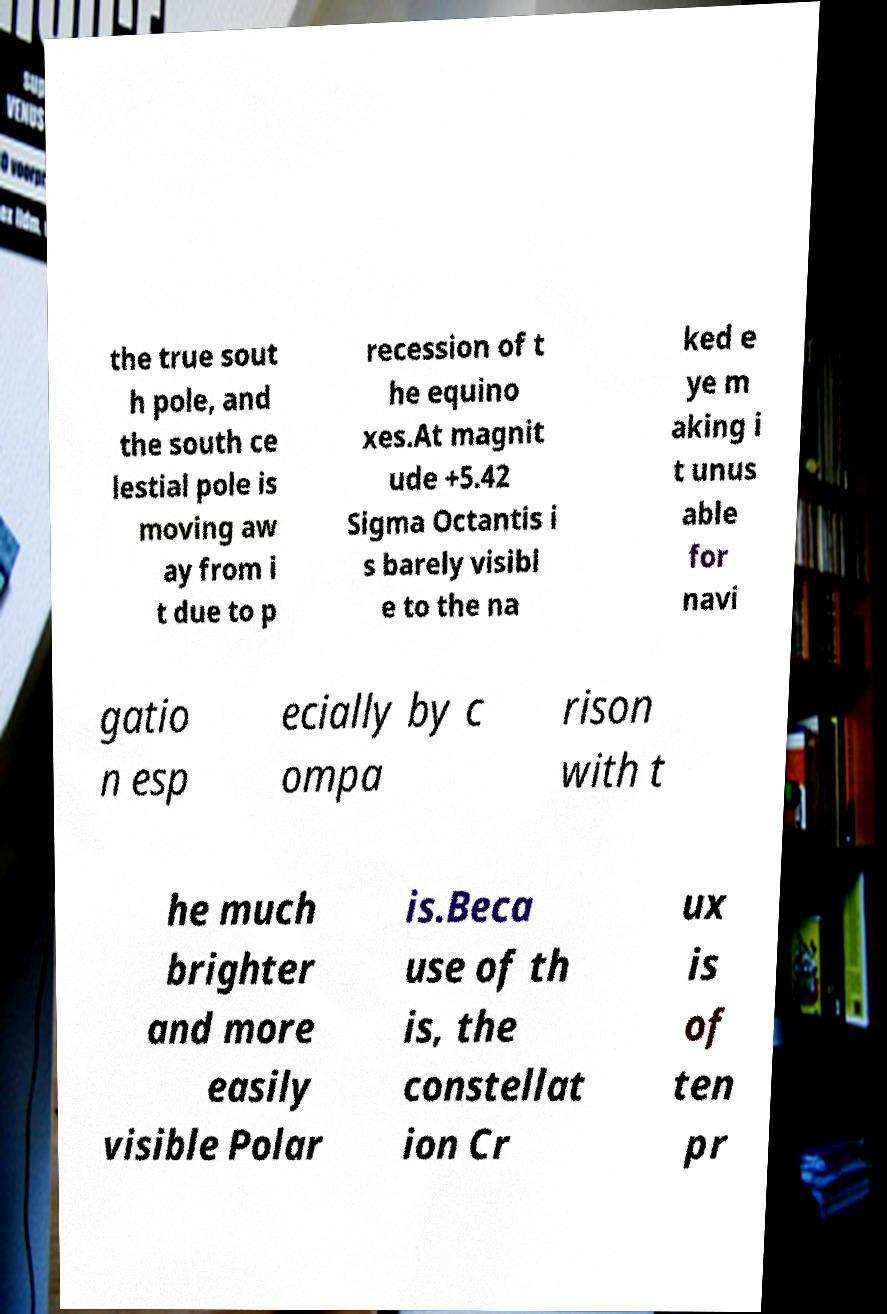Can you accurately transcribe the text from the provided image for me? the true sout h pole, and the south ce lestial pole is moving aw ay from i t due to p recession of t he equino xes.At magnit ude +5.42 Sigma Octantis i s barely visibl e to the na ked e ye m aking i t unus able for navi gatio n esp ecially by c ompa rison with t he much brighter and more easily visible Polar is.Beca use of th is, the constellat ion Cr ux is of ten pr 